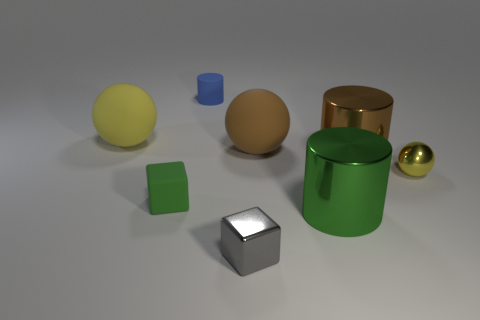Do the big metallic object that is in front of the shiny sphere and the brown shiny object have the same shape?
Your response must be concise. Yes. Are there more metal spheres that are on the right side of the large yellow matte ball than tiny red shiny cubes?
Ensure brevity in your answer.  Yes. What is the color of the cylinder that is the same size as the green metallic object?
Keep it short and to the point. Brown. What number of things are tiny things in front of the yellow rubber thing or small things?
Your answer should be compact. 4. What is the shape of the big object that is the same color as the matte cube?
Your response must be concise. Cylinder. There is a yellow thing in front of the large rubber sphere that is on the right side of the big yellow sphere; what is it made of?
Give a very brief answer. Metal. Is there a large sphere made of the same material as the small ball?
Offer a very short reply. No. Is there a yellow thing on the left side of the large brown thing that is in front of the big brown matte object?
Make the answer very short. Yes. There is a large brown object to the right of the brown rubber thing; what material is it?
Keep it short and to the point. Metal. Is the large green metal object the same shape as the blue matte thing?
Keep it short and to the point. Yes. 